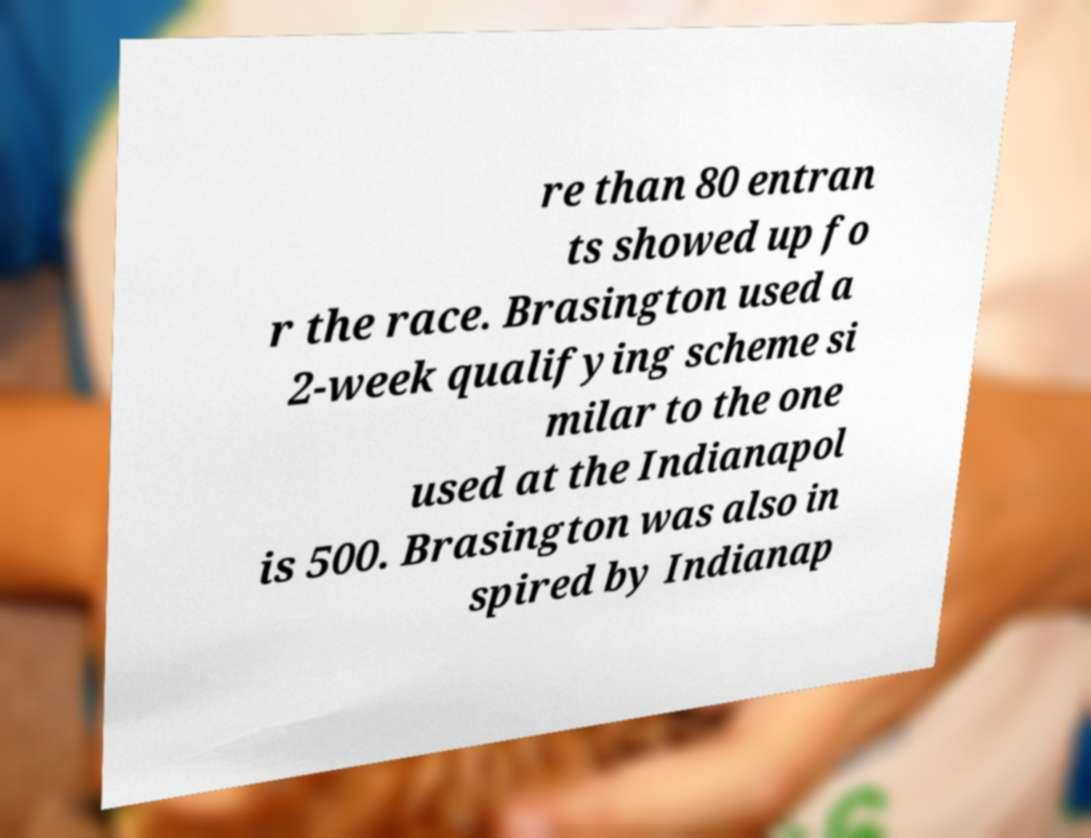Could you assist in decoding the text presented in this image and type it out clearly? re than 80 entran ts showed up fo r the race. Brasington used a 2-week qualifying scheme si milar to the one used at the Indianapol is 500. Brasington was also in spired by Indianap 